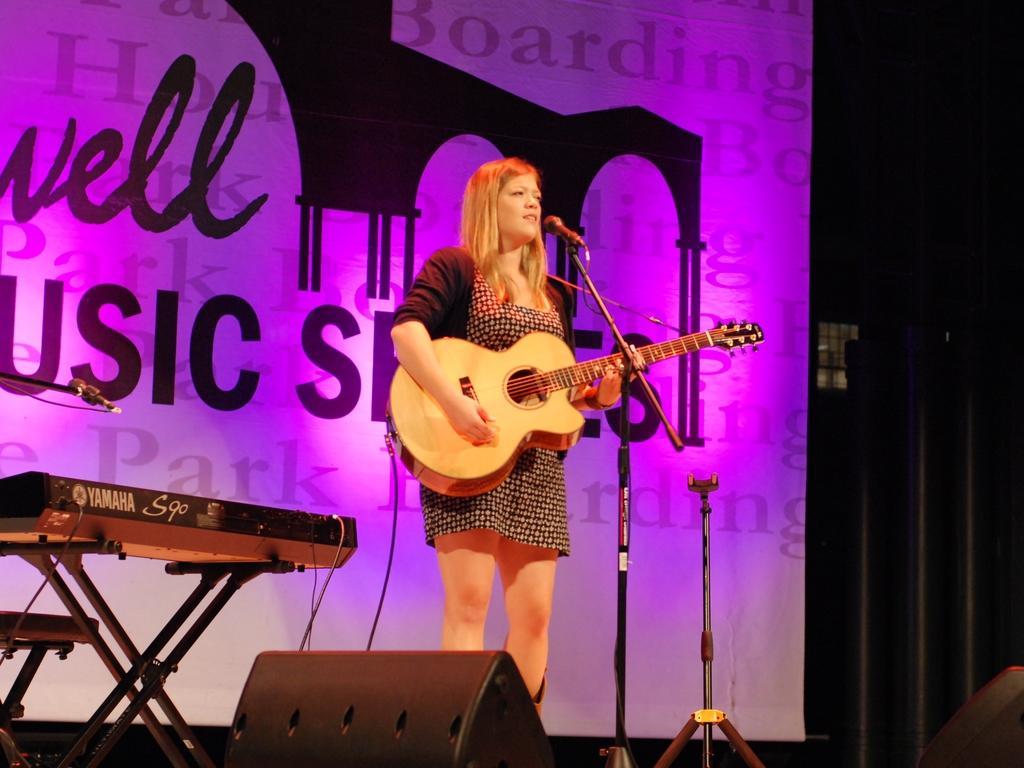How would you summarize this image in a sentence or two? In the image we can see there is a woman who is standing and holding guitar in her hand. 